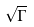Convert formula to latex. <formula><loc_0><loc_0><loc_500><loc_500>\sqrt { \Gamma }</formula> 